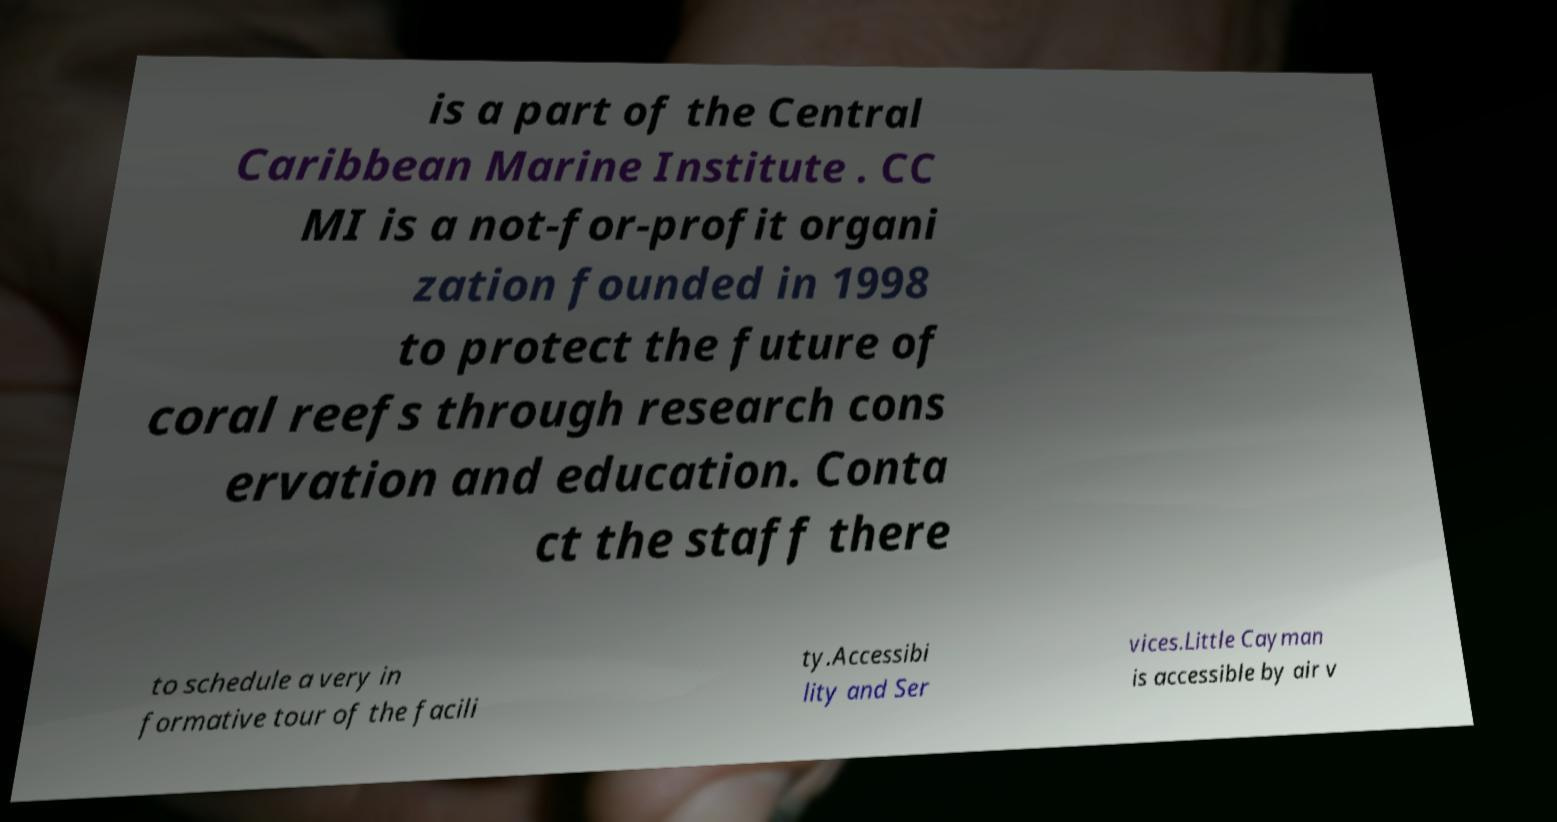I need the written content from this picture converted into text. Can you do that? is a part of the Central Caribbean Marine Institute . CC MI is a not-for-profit organi zation founded in 1998 to protect the future of coral reefs through research cons ervation and education. Conta ct the staff there to schedule a very in formative tour of the facili ty.Accessibi lity and Ser vices.Little Cayman is accessible by air v 